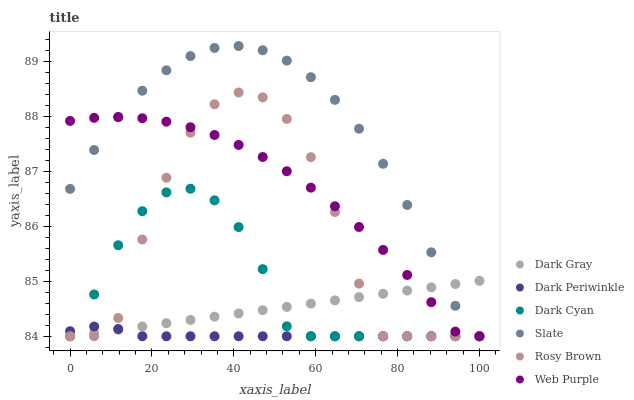Does Dark Periwinkle have the minimum area under the curve?
Answer yes or no. Yes. Does Slate have the maximum area under the curve?
Answer yes or no. Yes. Does Rosy Brown have the minimum area under the curve?
Answer yes or no. No. Does Rosy Brown have the maximum area under the curve?
Answer yes or no. No. Is Dark Gray the smoothest?
Answer yes or no. Yes. Is Rosy Brown the roughest?
Answer yes or no. Yes. Is Rosy Brown the smoothest?
Answer yes or no. No. Is Dark Gray the roughest?
Answer yes or no. No. Does Slate have the lowest value?
Answer yes or no. Yes. Does Slate have the highest value?
Answer yes or no. Yes. Does Rosy Brown have the highest value?
Answer yes or no. No. Does Dark Gray intersect Slate?
Answer yes or no. Yes. Is Dark Gray less than Slate?
Answer yes or no. No. Is Dark Gray greater than Slate?
Answer yes or no. No. 